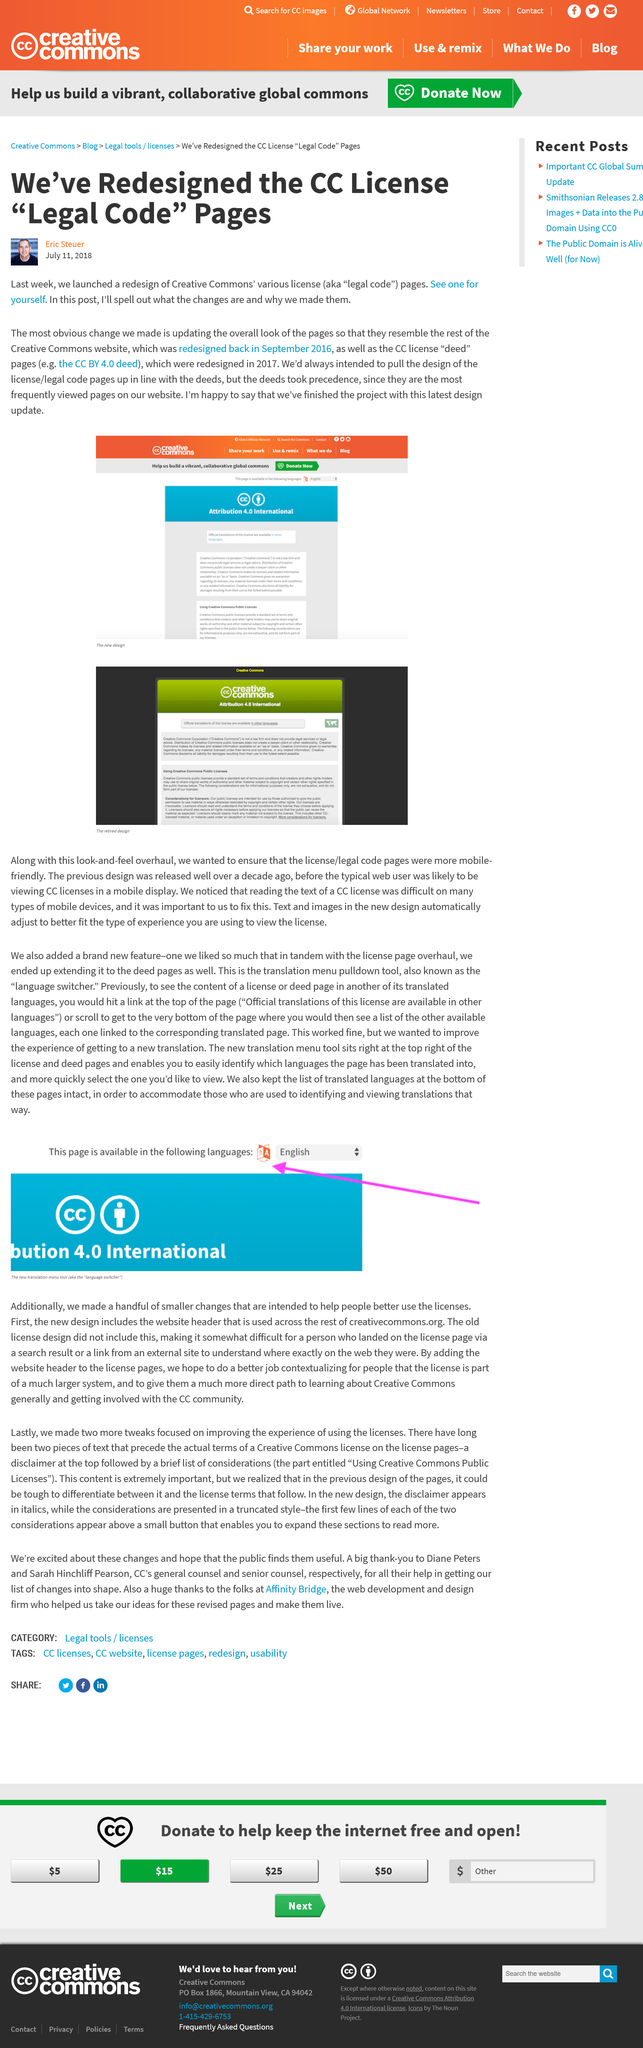Identify some key points in this picture. The deeds pages were prioritized because they are the most frequently viewed pages on the website. The most apparent modification made to the webpage was to revamp its overall visual appearance. The webpage has adopted a color scheme consisting of a white background, an orange banner with a blue header. 